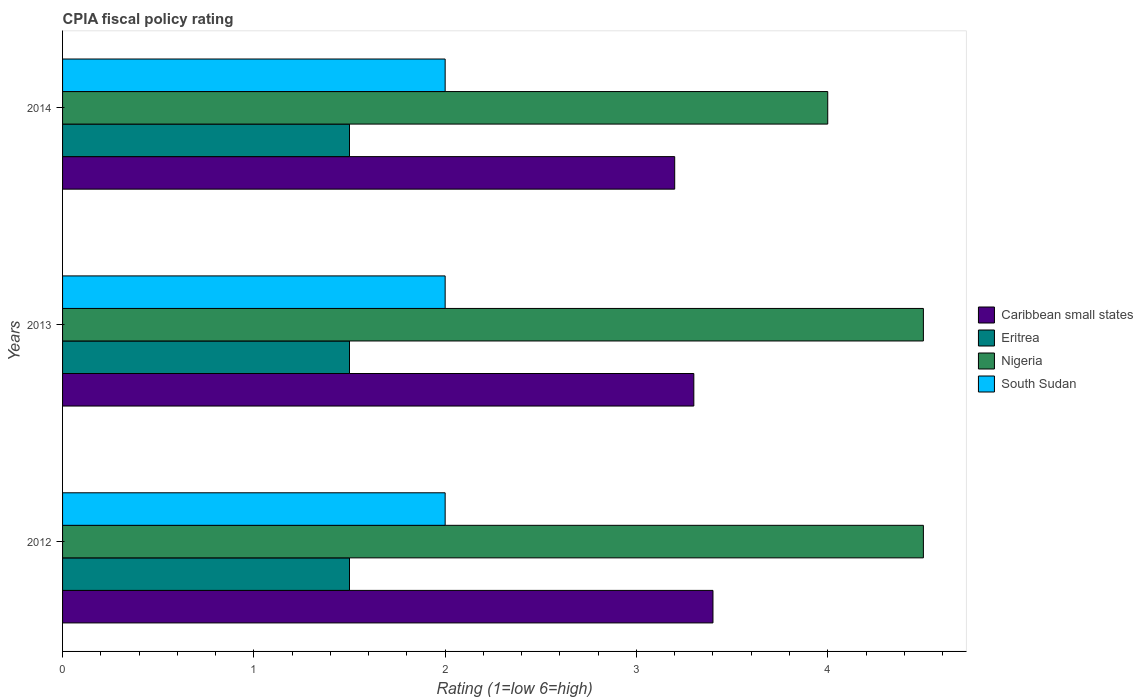How many different coloured bars are there?
Provide a succinct answer. 4. Are the number of bars per tick equal to the number of legend labels?
Give a very brief answer. Yes. How many bars are there on the 3rd tick from the bottom?
Your answer should be compact. 4. What is the CPIA rating in South Sudan in 2012?
Ensure brevity in your answer.  2. Across all years, what is the maximum CPIA rating in Nigeria?
Your answer should be compact. 4.5. In which year was the CPIA rating in Eritrea maximum?
Give a very brief answer. 2012. In which year was the CPIA rating in Eritrea minimum?
Ensure brevity in your answer.  2012. What is the difference between the CPIA rating in Caribbean small states in 2012 and that in 2013?
Offer a terse response. 0.1. What is the difference between the CPIA rating in Caribbean small states in 2014 and the CPIA rating in South Sudan in 2013?
Provide a short and direct response. 1.2. What is the average CPIA rating in South Sudan per year?
Offer a very short reply. 2. What is the ratio of the CPIA rating in Nigeria in 2012 to that in 2014?
Your response must be concise. 1.12. Is the difference between the CPIA rating in Nigeria in 2013 and 2014 greater than the difference between the CPIA rating in Eritrea in 2013 and 2014?
Make the answer very short. Yes. What is the difference between the highest and the second highest CPIA rating in Caribbean small states?
Offer a very short reply. 0.1. In how many years, is the CPIA rating in Nigeria greater than the average CPIA rating in Nigeria taken over all years?
Your response must be concise. 2. Is it the case that in every year, the sum of the CPIA rating in South Sudan and CPIA rating in Eritrea is greater than the sum of CPIA rating in Caribbean small states and CPIA rating in Nigeria?
Offer a terse response. Yes. What does the 2nd bar from the top in 2013 represents?
Give a very brief answer. Nigeria. What does the 4th bar from the bottom in 2012 represents?
Your answer should be very brief. South Sudan. Is it the case that in every year, the sum of the CPIA rating in Caribbean small states and CPIA rating in Eritrea is greater than the CPIA rating in Nigeria?
Keep it short and to the point. Yes. How many bars are there?
Your answer should be very brief. 12. What is the difference between two consecutive major ticks on the X-axis?
Provide a succinct answer. 1. Are the values on the major ticks of X-axis written in scientific E-notation?
Offer a very short reply. No. Does the graph contain any zero values?
Give a very brief answer. No. Where does the legend appear in the graph?
Your response must be concise. Center right. How are the legend labels stacked?
Provide a succinct answer. Vertical. What is the title of the graph?
Make the answer very short. CPIA fiscal policy rating. What is the label or title of the Y-axis?
Keep it short and to the point. Years. What is the Rating (1=low 6=high) of South Sudan in 2012?
Keep it short and to the point. 2. What is the Rating (1=low 6=high) of Caribbean small states in 2013?
Make the answer very short. 3.3. What is the Rating (1=low 6=high) of Nigeria in 2013?
Offer a very short reply. 4.5. What is the Rating (1=low 6=high) in Caribbean small states in 2014?
Ensure brevity in your answer.  3.2. What is the Rating (1=low 6=high) in Eritrea in 2014?
Your response must be concise. 1.5. Across all years, what is the maximum Rating (1=low 6=high) of Caribbean small states?
Give a very brief answer. 3.4. Across all years, what is the maximum Rating (1=low 6=high) of Eritrea?
Ensure brevity in your answer.  1.5. Across all years, what is the maximum Rating (1=low 6=high) of Nigeria?
Provide a short and direct response. 4.5. Across all years, what is the maximum Rating (1=low 6=high) in South Sudan?
Offer a terse response. 2. Across all years, what is the minimum Rating (1=low 6=high) of Nigeria?
Your response must be concise. 4. What is the total Rating (1=low 6=high) of Nigeria in the graph?
Your response must be concise. 13. What is the difference between the Rating (1=low 6=high) of Caribbean small states in 2012 and that in 2013?
Your response must be concise. 0.1. What is the difference between the Rating (1=low 6=high) in Eritrea in 2012 and that in 2013?
Give a very brief answer. 0. What is the difference between the Rating (1=low 6=high) in Nigeria in 2012 and that in 2013?
Offer a very short reply. 0. What is the difference between the Rating (1=low 6=high) in Nigeria in 2012 and that in 2014?
Provide a short and direct response. 0.5. What is the difference between the Rating (1=low 6=high) of South Sudan in 2012 and that in 2014?
Provide a short and direct response. 0. What is the difference between the Rating (1=low 6=high) in Caribbean small states in 2013 and that in 2014?
Make the answer very short. 0.1. What is the difference between the Rating (1=low 6=high) of Eritrea in 2013 and that in 2014?
Your answer should be compact. 0. What is the difference between the Rating (1=low 6=high) in Nigeria in 2013 and that in 2014?
Ensure brevity in your answer.  0.5. What is the difference between the Rating (1=low 6=high) in South Sudan in 2013 and that in 2014?
Provide a succinct answer. 0. What is the difference between the Rating (1=low 6=high) in Caribbean small states in 2012 and the Rating (1=low 6=high) in Eritrea in 2013?
Offer a very short reply. 1.9. What is the difference between the Rating (1=low 6=high) of Caribbean small states in 2012 and the Rating (1=low 6=high) of Nigeria in 2013?
Your response must be concise. -1.1. What is the difference between the Rating (1=low 6=high) of Caribbean small states in 2012 and the Rating (1=low 6=high) of South Sudan in 2013?
Ensure brevity in your answer.  1.4. What is the difference between the Rating (1=low 6=high) in Eritrea in 2012 and the Rating (1=low 6=high) in Nigeria in 2013?
Your response must be concise. -3. What is the difference between the Rating (1=low 6=high) in Nigeria in 2012 and the Rating (1=low 6=high) in South Sudan in 2013?
Provide a succinct answer. 2.5. What is the difference between the Rating (1=low 6=high) of Caribbean small states in 2012 and the Rating (1=low 6=high) of Eritrea in 2014?
Your response must be concise. 1.9. What is the difference between the Rating (1=low 6=high) in Caribbean small states in 2012 and the Rating (1=low 6=high) in Nigeria in 2014?
Provide a succinct answer. -0.6. What is the difference between the Rating (1=low 6=high) in Eritrea in 2012 and the Rating (1=low 6=high) in Nigeria in 2014?
Offer a very short reply. -2.5. What is the difference between the Rating (1=low 6=high) of Eritrea in 2012 and the Rating (1=low 6=high) of South Sudan in 2014?
Your answer should be very brief. -0.5. What is the difference between the Rating (1=low 6=high) of Nigeria in 2012 and the Rating (1=low 6=high) of South Sudan in 2014?
Ensure brevity in your answer.  2.5. What is the difference between the Rating (1=low 6=high) of Caribbean small states in 2013 and the Rating (1=low 6=high) of Nigeria in 2014?
Your answer should be very brief. -0.7. What is the difference between the Rating (1=low 6=high) in Eritrea in 2013 and the Rating (1=low 6=high) in Nigeria in 2014?
Give a very brief answer. -2.5. What is the difference between the Rating (1=low 6=high) in Nigeria in 2013 and the Rating (1=low 6=high) in South Sudan in 2014?
Give a very brief answer. 2.5. What is the average Rating (1=low 6=high) of Caribbean small states per year?
Provide a succinct answer. 3.3. What is the average Rating (1=low 6=high) of Nigeria per year?
Your answer should be compact. 4.33. What is the average Rating (1=low 6=high) of South Sudan per year?
Your response must be concise. 2. In the year 2012, what is the difference between the Rating (1=low 6=high) in Caribbean small states and Rating (1=low 6=high) in Eritrea?
Provide a short and direct response. 1.9. In the year 2012, what is the difference between the Rating (1=low 6=high) in Caribbean small states and Rating (1=low 6=high) in Nigeria?
Your answer should be very brief. -1.1. In the year 2013, what is the difference between the Rating (1=low 6=high) in Caribbean small states and Rating (1=low 6=high) in Eritrea?
Keep it short and to the point. 1.8. In the year 2013, what is the difference between the Rating (1=low 6=high) of Caribbean small states and Rating (1=low 6=high) of Nigeria?
Your answer should be very brief. -1.2. In the year 2013, what is the difference between the Rating (1=low 6=high) of Eritrea and Rating (1=low 6=high) of Nigeria?
Offer a terse response. -3. In the year 2013, what is the difference between the Rating (1=low 6=high) in Nigeria and Rating (1=low 6=high) in South Sudan?
Offer a very short reply. 2.5. In the year 2014, what is the difference between the Rating (1=low 6=high) in Caribbean small states and Rating (1=low 6=high) in Nigeria?
Your response must be concise. -0.8. In the year 2014, what is the difference between the Rating (1=low 6=high) of Caribbean small states and Rating (1=low 6=high) of South Sudan?
Make the answer very short. 1.2. In the year 2014, what is the difference between the Rating (1=low 6=high) of Eritrea and Rating (1=low 6=high) of Nigeria?
Your response must be concise. -2.5. In the year 2014, what is the difference between the Rating (1=low 6=high) in Eritrea and Rating (1=low 6=high) in South Sudan?
Keep it short and to the point. -0.5. What is the ratio of the Rating (1=low 6=high) in Caribbean small states in 2012 to that in 2013?
Give a very brief answer. 1.03. What is the ratio of the Rating (1=low 6=high) in Eritrea in 2012 to that in 2013?
Make the answer very short. 1. What is the ratio of the Rating (1=low 6=high) of Nigeria in 2012 to that in 2013?
Provide a short and direct response. 1. What is the ratio of the Rating (1=low 6=high) in South Sudan in 2012 to that in 2013?
Offer a very short reply. 1. What is the ratio of the Rating (1=low 6=high) in Caribbean small states in 2012 to that in 2014?
Provide a succinct answer. 1.06. What is the ratio of the Rating (1=low 6=high) in Eritrea in 2012 to that in 2014?
Provide a short and direct response. 1. What is the ratio of the Rating (1=low 6=high) in Nigeria in 2012 to that in 2014?
Your answer should be compact. 1.12. What is the ratio of the Rating (1=low 6=high) in South Sudan in 2012 to that in 2014?
Ensure brevity in your answer.  1. What is the ratio of the Rating (1=low 6=high) in Caribbean small states in 2013 to that in 2014?
Give a very brief answer. 1.03. What is the ratio of the Rating (1=low 6=high) in Nigeria in 2013 to that in 2014?
Offer a terse response. 1.12. What is the difference between the highest and the second highest Rating (1=low 6=high) in Nigeria?
Provide a short and direct response. 0. What is the difference between the highest and the second highest Rating (1=low 6=high) of South Sudan?
Provide a succinct answer. 0. What is the difference between the highest and the lowest Rating (1=low 6=high) in Caribbean small states?
Provide a short and direct response. 0.2. What is the difference between the highest and the lowest Rating (1=low 6=high) of Eritrea?
Keep it short and to the point. 0. 